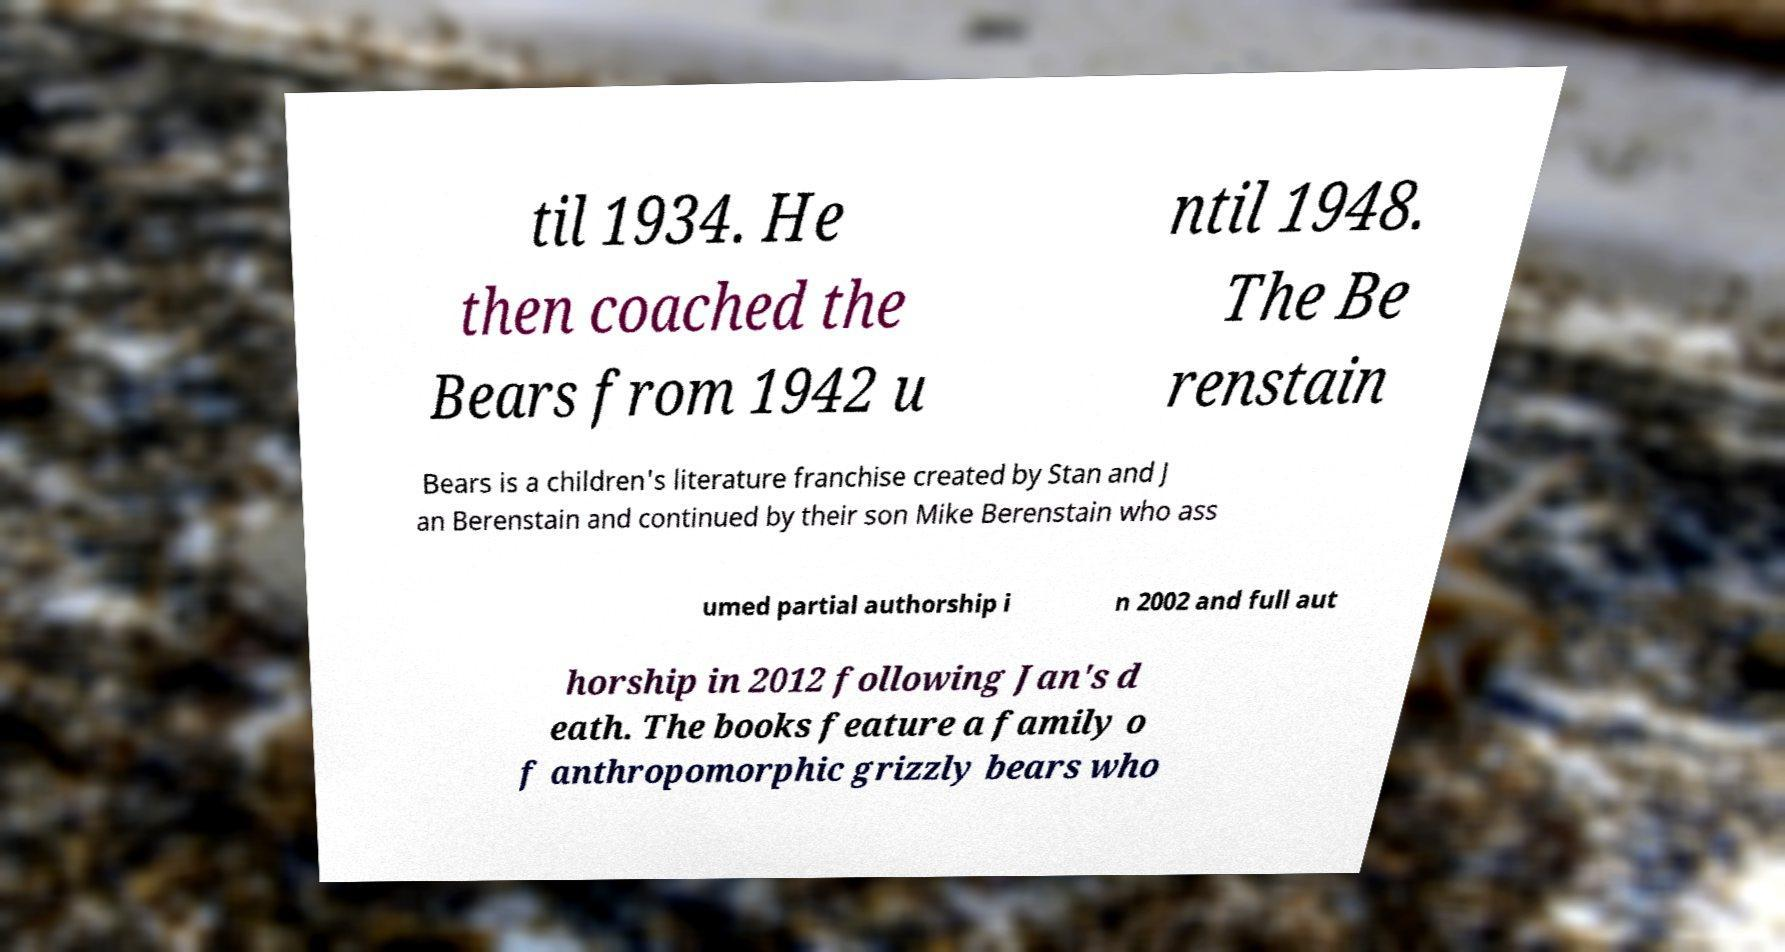For documentation purposes, I need the text within this image transcribed. Could you provide that? til 1934. He then coached the Bears from 1942 u ntil 1948. The Be renstain Bears is a children's literature franchise created by Stan and J an Berenstain and continued by their son Mike Berenstain who ass umed partial authorship i n 2002 and full aut horship in 2012 following Jan's d eath. The books feature a family o f anthropomorphic grizzly bears who 